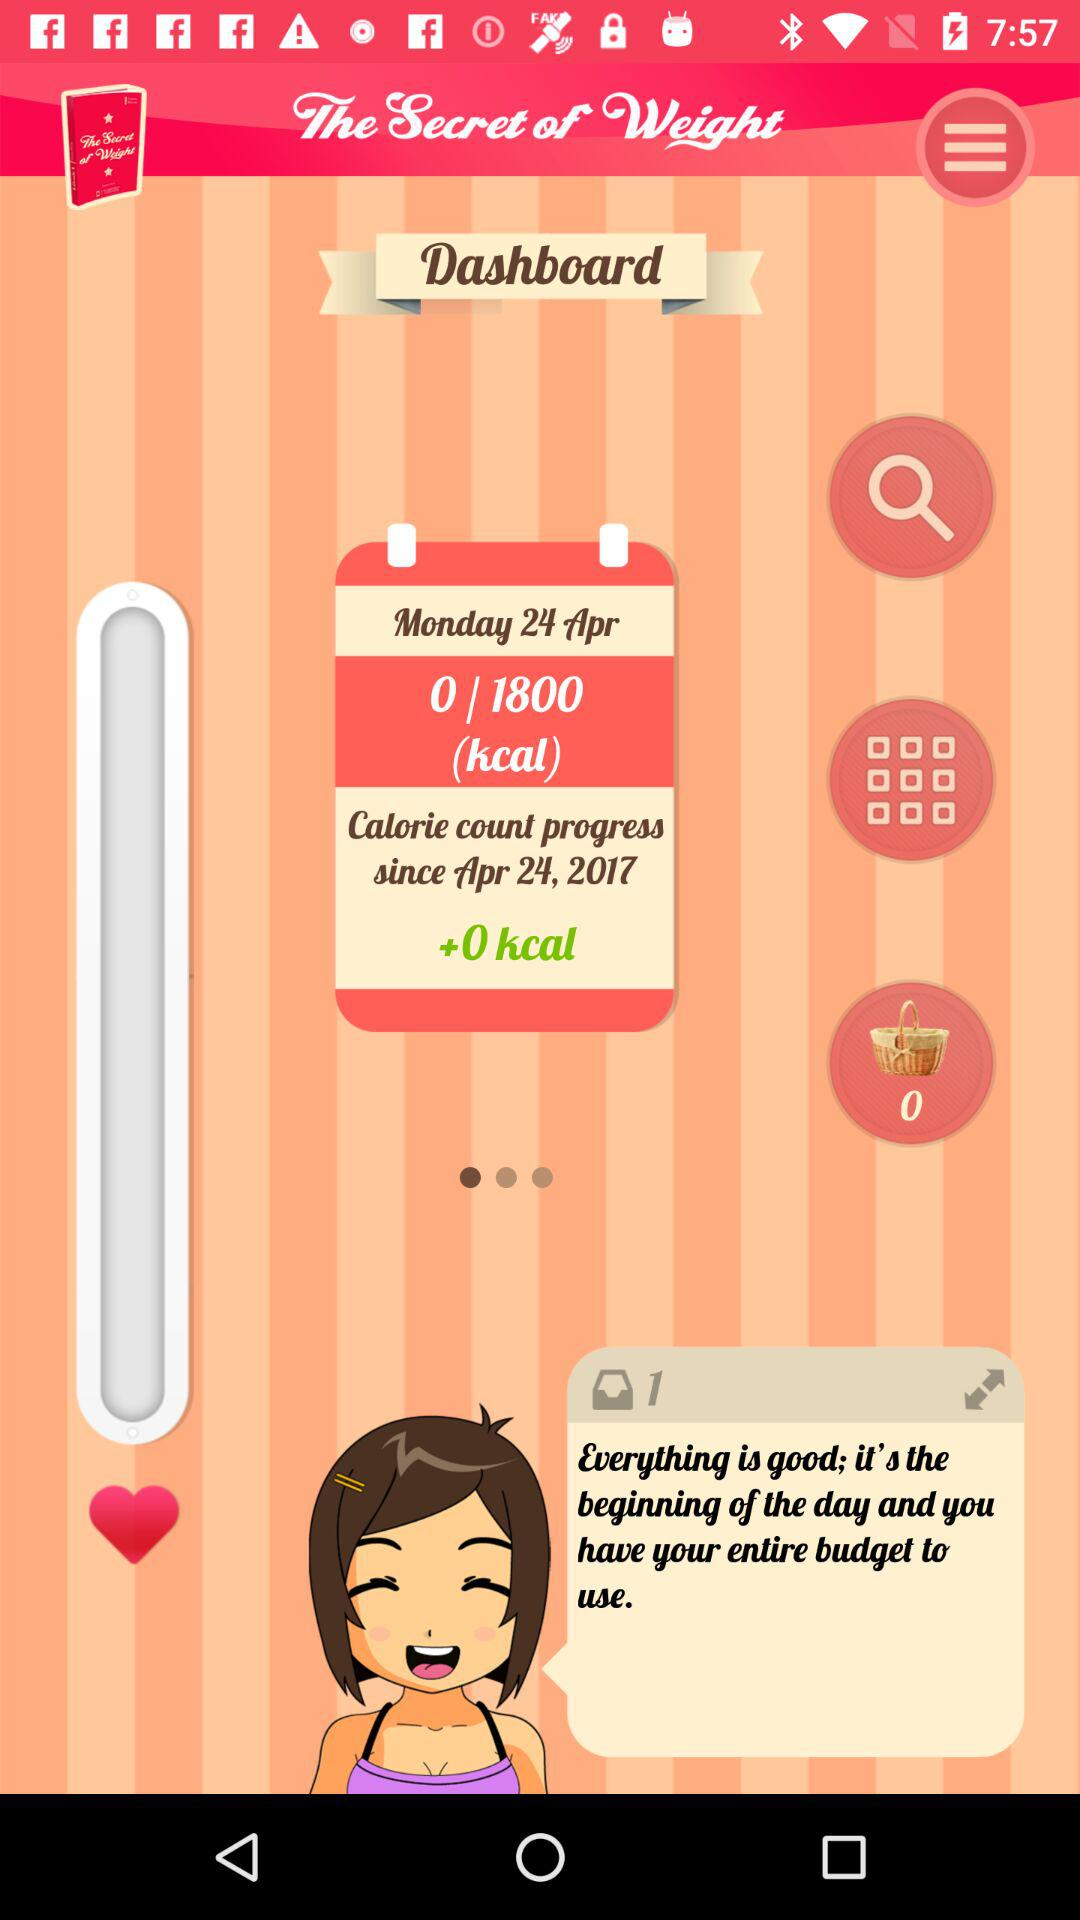How many calories are consumed today?
Answer the question using a single word or phrase. 0 